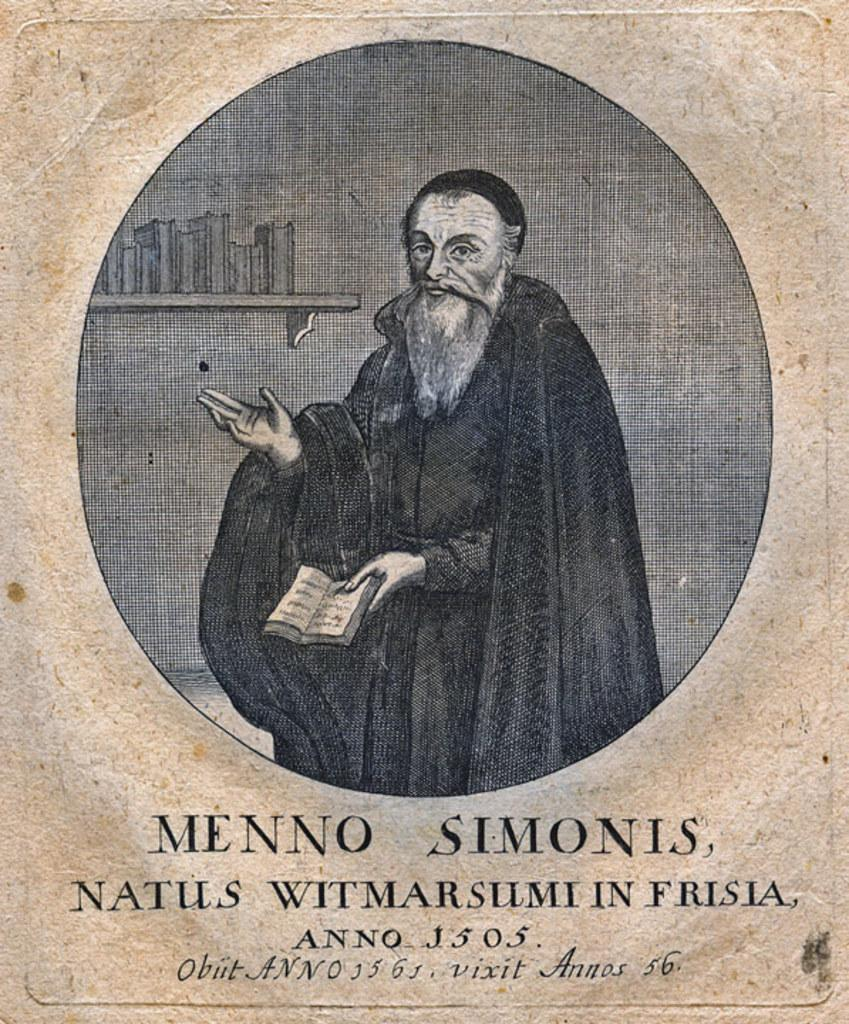What is the main subject of the image? There is a photo of a man in the image. Can you describe any additional elements in the image? There is text at the bottom of the image. What type of plastic material is used to create the stage in the image? There is no stage present in the image; it only features a photo of a man and text at the bottom. 